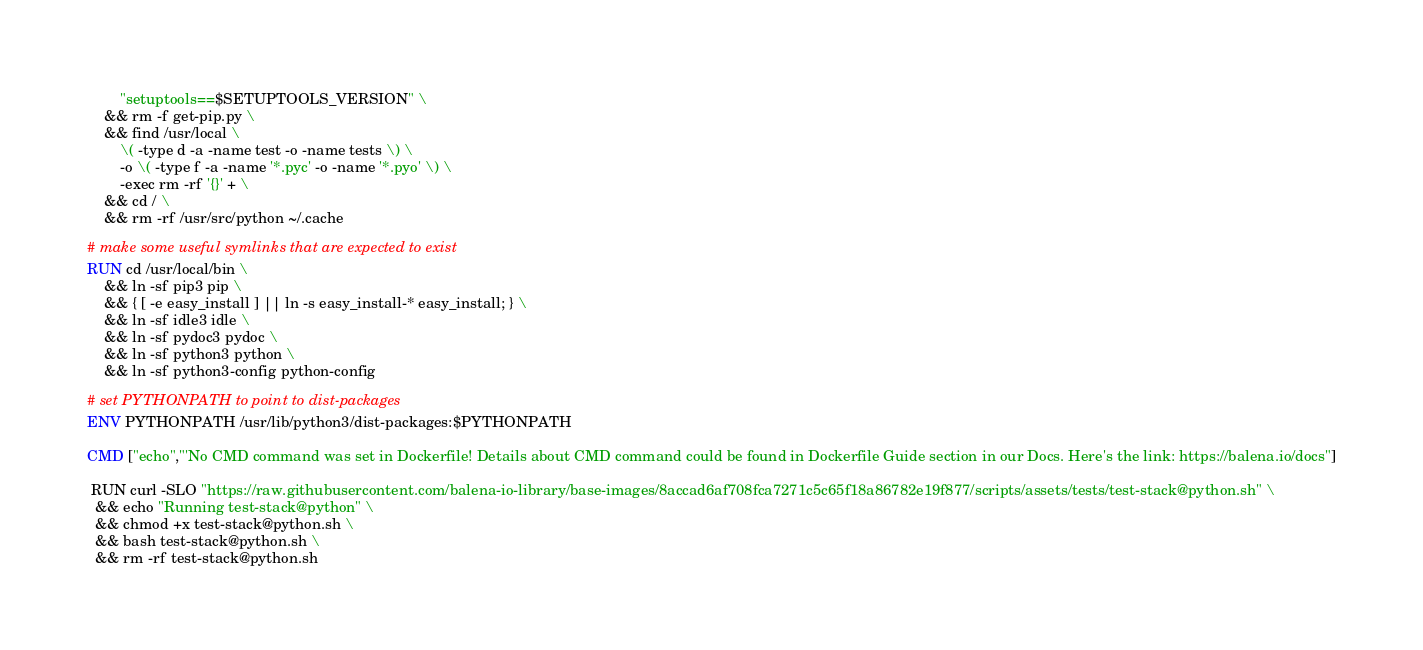Convert code to text. <code><loc_0><loc_0><loc_500><loc_500><_Dockerfile_>        "setuptools==$SETUPTOOLS_VERSION" \
	&& rm -f get-pip.py \
	&& find /usr/local \
		\( -type d -a -name test -o -name tests \) \
		-o \( -type f -a -name '*.pyc' -o -name '*.pyo' \) \
		-exec rm -rf '{}' + \
	&& cd / \
	&& rm -rf /usr/src/python ~/.cache

# make some useful symlinks that are expected to exist
RUN cd /usr/local/bin \
	&& ln -sf pip3 pip \
	&& { [ -e easy_install ] || ln -s easy_install-* easy_install; } \
	&& ln -sf idle3 idle \
	&& ln -sf pydoc3 pydoc \
	&& ln -sf python3 python \
	&& ln -sf python3-config python-config

# set PYTHONPATH to point to dist-packages
ENV PYTHONPATH /usr/lib/python3/dist-packages:$PYTHONPATH

CMD ["echo","'No CMD command was set in Dockerfile! Details about CMD command could be found in Dockerfile Guide section in our Docs. Here's the link: https://balena.io/docs"]

 RUN curl -SLO "https://raw.githubusercontent.com/balena-io-library/base-images/8accad6af708fca7271c5c65f18a86782e19f877/scripts/assets/tests/test-stack@python.sh" \
  && echo "Running test-stack@python" \
  && chmod +x test-stack@python.sh \
  && bash test-stack@python.sh \
  && rm -rf test-stack@python.sh 
</code> 